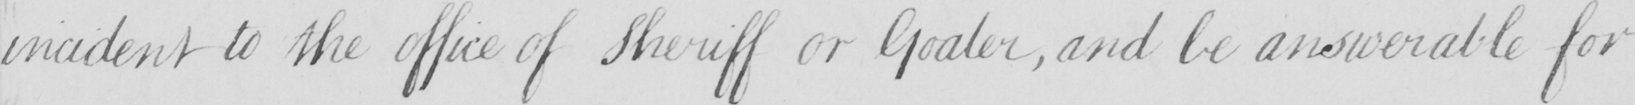What text is written in this handwritten line? incident to the office of Sheriff or Goaler  , and be answerable for 